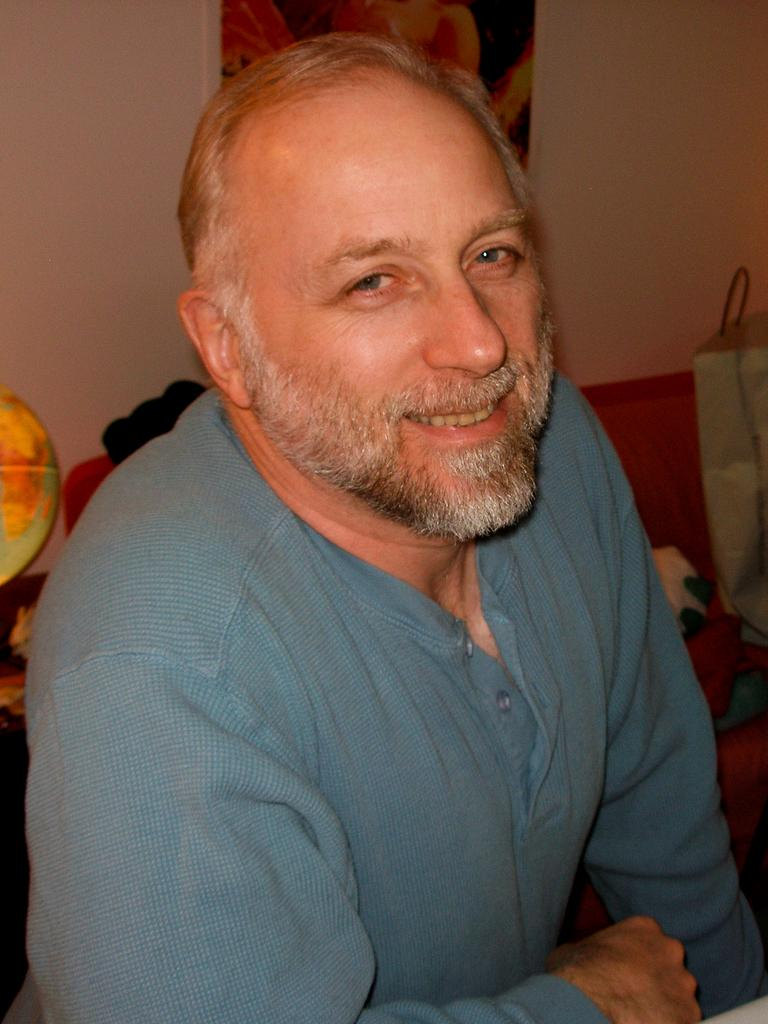Who is present in the image? There is a man in the image. What expression does the man have? The man is smiling. What can be seen behind the man? There are objects behind the man. What is the background of the man? There is a wall behind the man. What type of muscle does the stranger have in the image? There is no stranger present in the image, and therefore no information about their muscles can be provided. 